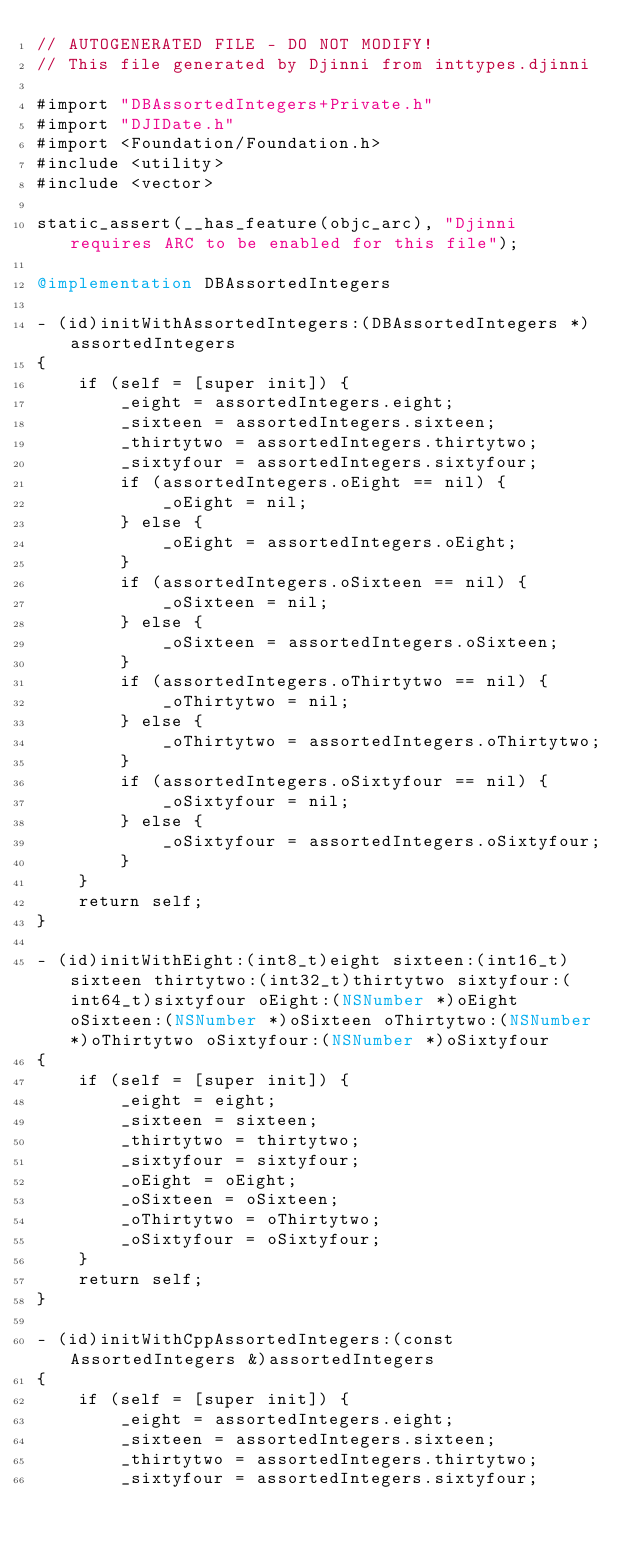<code> <loc_0><loc_0><loc_500><loc_500><_ObjectiveC_>// AUTOGENERATED FILE - DO NOT MODIFY!
// This file generated by Djinni from inttypes.djinni

#import "DBAssortedIntegers+Private.h"
#import "DJIDate.h"
#import <Foundation/Foundation.h>
#include <utility>
#include <vector>

static_assert(__has_feature(objc_arc), "Djinni requires ARC to be enabled for this file");

@implementation DBAssortedIntegers

- (id)initWithAssortedIntegers:(DBAssortedIntegers *)assortedIntegers
{
    if (self = [super init]) {
        _eight = assortedIntegers.eight;
        _sixteen = assortedIntegers.sixteen;
        _thirtytwo = assortedIntegers.thirtytwo;
        _sixtyfour = assortedIntegers.sixtyfour;
        if (assortedIntegers.oEight == nil) {
            _oEight = nil;
        } else {
            _oEight = assortedIntegers.oEight;
        }
        if (assortedIntegers.oSixteen == nil) {
            _oSixteen = nil;
        } else {
            _oSixteen = assortedIntegers.oSixteen;
        }
        if (assortedIntegers.oThirtytwo == nil) {
            _oThirtytwo = nil;
        } else {
            _oThirtytwo = assortedIntegers.oThirtytwo;
        }
        if (assortedIntegers.oSixtyfour == nil) {
            _oSixtyfour = nil;
        } else {
            _oSixtyfour = assortedIntegers.oSixtyfour;
        }
    }
    return self;
}

- (id)initWithEight:(int8_t)eight sixteen:(int16_t)sixteen thirtytwo:(int32_t)thirtytwo sixtyfour:(int64_t)sixtyfour oEight:(NSNumber *)oEight oSixteen:(NSNumber *)oSixteen oThirtytwo:(NSNumber *)oThirtytwo oSixtyfour:(NSNumber *)oSixtyfour
{
    if (self = [super init]) {
        _eight = eight;
        _sixteen = sixteen;
        _thirtytwo = thirtytwo;
        _sixtyfour = sixtyfour;
        _oEight = oEight;
        _oSixteen = oSixteen;
        _oThirtytwo = oThirtytwo;
        _oSixtyfour = oSixtyfour;
    }
    return self;
}

- (id)initWithCppAssortedIntegers:(const AssortedIntegers &)assortedIntegers
{
    if (self = [super init]) {
        _eight = assortedIntegers.eight;
        _sixteen = assortedIntegers.sixteen;
        _thirtytwo = assortedIntegers.thirtytwo;
        _sixtyfour = assortedIntegers.sixtyfour;</code> 